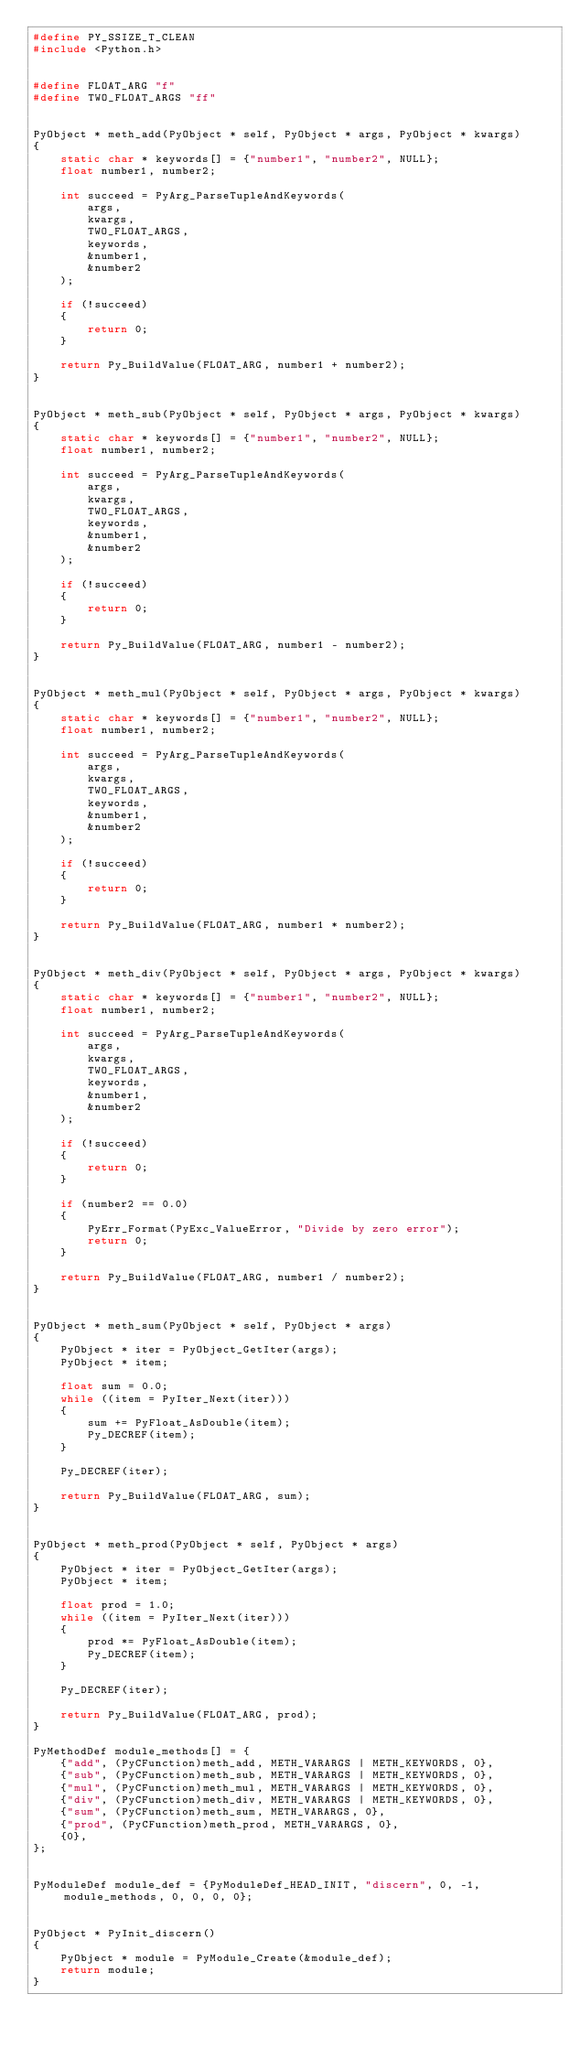Convert code to text. <code><loc_0><loc_0><loc_500><loc_500><_C_>#define PY_SSIZE_T_CLEAN
#include <Python.h>


#define FLOAT_ARG "f"
#define TWO_FLOAT_ARGS "ff"


PyObject * meth_add(PyObject * self, PyObject * args, PyObject * kwargs)
{
    static char * keywords[] = {"number1", "number2", NULL};
    float number1, number2;

    int succeed = PyArg_ParseTupleAndKeywords(
        args,
        kwargs,
        TWO_FLOAT_ARGS,
        keywords,
        &number1,
        &number2
    );

    if (!succeed)
    {
        return 0;
    }

    return Py_BuildValue(FLOAT_ARG, number1 + number2);
}


PyObject * meth_sub(PyObject * self, PyObject * args, PyObject * kwargs)
{
    static char * keywords[] = {"number1", "number2", NULL};
    float number1, number2;

    int succeed = PyArg_ParseTupleAndKeywords(
        args,
        kwargs,
        TWO_FLOAT_ARGS,
        keywords,
        &number1,
        &number2
    );

    if (!succeed)
    {
        return 0;
    }

    return Py_BuildValue(FLOAT_ARG, number1 - number2);
}


PyObject * meth_mul(PyObject * self, PyObject * args, PyObject * kwargs)
{
    static char * keywords[] = {"number1", "number2", NULL};
    float number1, number2;

    int succeed = PyArg_ParseTupleAndKeywords(
        args,
        kwargs,
        TWO_FLOAT_ARGS,
        keywords,
        &number1,
        &number2
    );

    if (!succeed)
    {
        return 0;
    }

    return Py_BuildValue(FLOAT_ARG, number1 * number2);
}


PyObject * meth_div(PyObject * self, PyObject * args, PyObject * kwargs)
{
    static char * keywords[] = {"number1", "number2", NULL};
    float number1, number2;

    int succeed = PyArg_ParseTupleAndKeywords(
        args,
        kwargs,
        TWO_FLOAT_ARGS,
        keywords,
        &number1,
        &number2
    );

    if (!succeed)
    {
        return 0;
    }

    if (number2 == 0.0)
    {
        PyErr_Format(PyExc_ValueError, "Divide by zero error");
        return 0;
    }

    return Py_BuildValue(FLOAT_ARG, number1 / number2);
}


PyObject * meth_sum(PyObject * self, PyObject * args)
{
    PyObject * iter = PyObject_GetIter(args);
    PyObject * item;

    float sum = 0.0;
    while ((item = PyIter_Next(iter)))
    {
        sum += PyFloat_AsDouble(item);
        Py_DECREF(item);
    }

    Py_DECREF(iter);

    return Py_BuildValue(FLOAT_ARG, sum);
}


PyObject * meth_prod(PyObject * self, PyObject * args)
{
    PyObject * iter = PyObject_GetIter(args);
    PyObject * item;

    float prod = 1.0;
    while ((item = PyIter_Next(iter)))
    {
        prod *= PyFloat_AsDouble(item);
        Py_DECREF(item);
    }

    Py_DECREF(iter);

    return Py_BuildValue(FLOAT_ARG, prod);
}

PyMethodDef module_methods[] = {
    {"add", (PyCFunction)meth_add, METH_VARARGS | METH_KEYWORDS, 0},
    {"sub", (PyCFunction)meth_sub, METH_VARARGS | METH_KEYWORDS, 0},
    {"mul", (PyCFunction)meth_mul, METH_VARARGS | METH_KEYWORDS, 0},
    {"div", (PyCFunction)meth_div, METH_VARARGS | METH_KEYWORDS, 0},
    {"sum", (PyCFunction)meth_sum, METH_VARARGS, 0},
    {"prod", (PyCFunction)meth_prod, METH_VARARGS, 0},
    {0},
};


PyModuleDef module_def = {PyModuleDef_HEAD_INIT, "discern", 0, -1, module_methods, 0, 0, 0, 0};


PyObject * PyInit_discern()
{
    PyObject * module = PyModule_Create(&module_def);
    return module;
}
</code> 